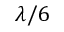<formula> <loc_0><loc_0><loc_500><loc_500>\lambda / 6</formula> 